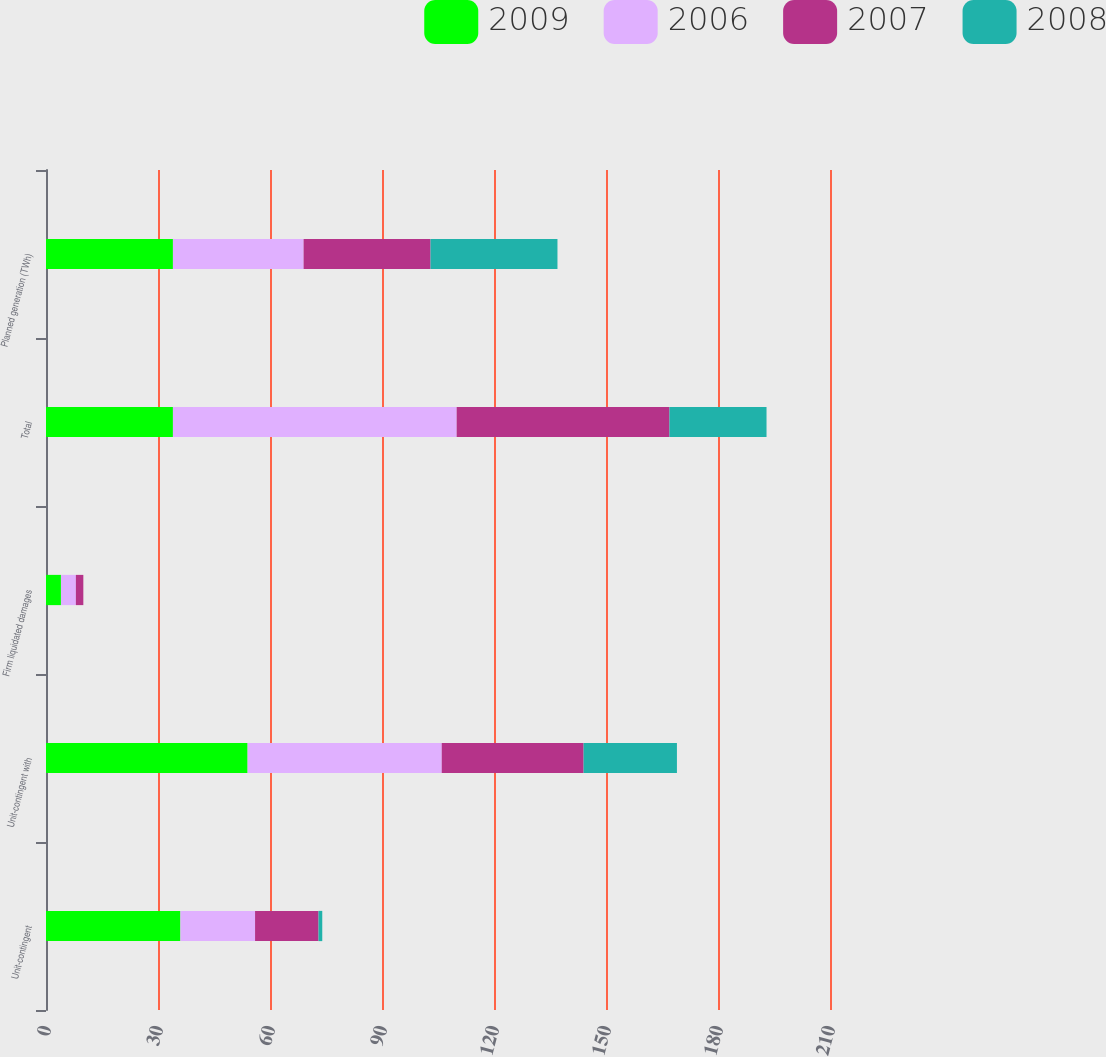Convert chart to OTSL. <chart><loc_0><loc_0><loc_500><loc_500><stacked_bar_chart><ecel><fcel>Unit-contingent<fcel>Unit-contingent with<fcel>Firm liquidated damages<fcel>Total<fcel>Planned generation (TWh)<nl><fcel>2009<fcel>36<fcel>54<fcel>4<fcel>34<fcel>34<nl><fcel>2006<fcel>20<fcel>52<fcel>4<fcel>76<fcel>35<nl><fcel>2007<fcel>17<fcel>38<fcel>2<fcel>57<fcel>34<nl><fcel>2008<fcel>1<fcel>25<fcel>0<fcel>26<fcel>34<nl></chart> 